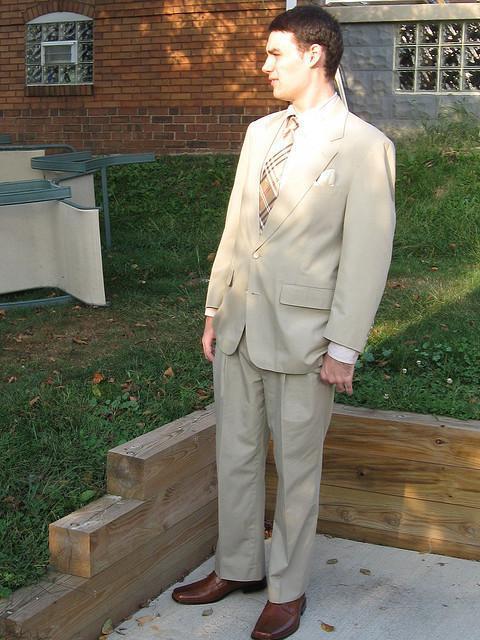How many benches are in the picture?
Give a very brief answer. 1. How many people can you see?
Give a very brief answer. 1. 